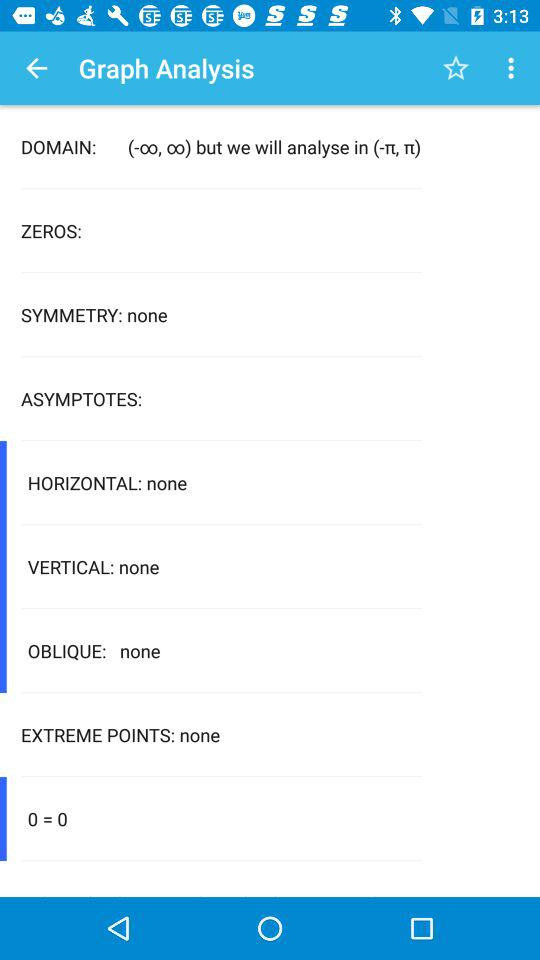What is mentioned in "HORIZONTAL"? In "HORIZONTAL", none is mentioned. 